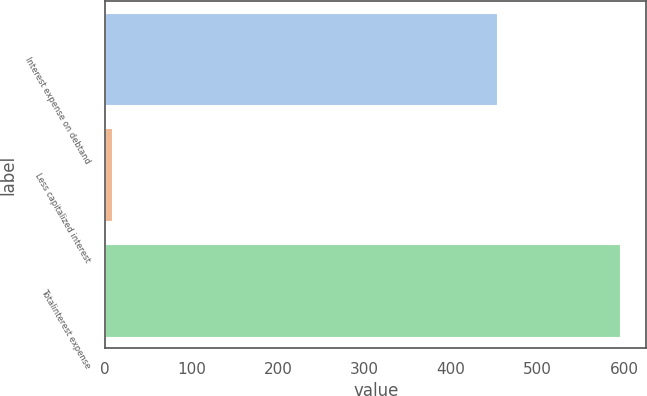<chart> <loc_0><loc_0><loc_500><loc_500><bar_chart><fcel>Interest expense on debtand<fcel>Less capitalized interest<fcel>Totalinterest expense<nl><fcel>453.5<fcel>7.8<fcel>595.9<nl></chart> 